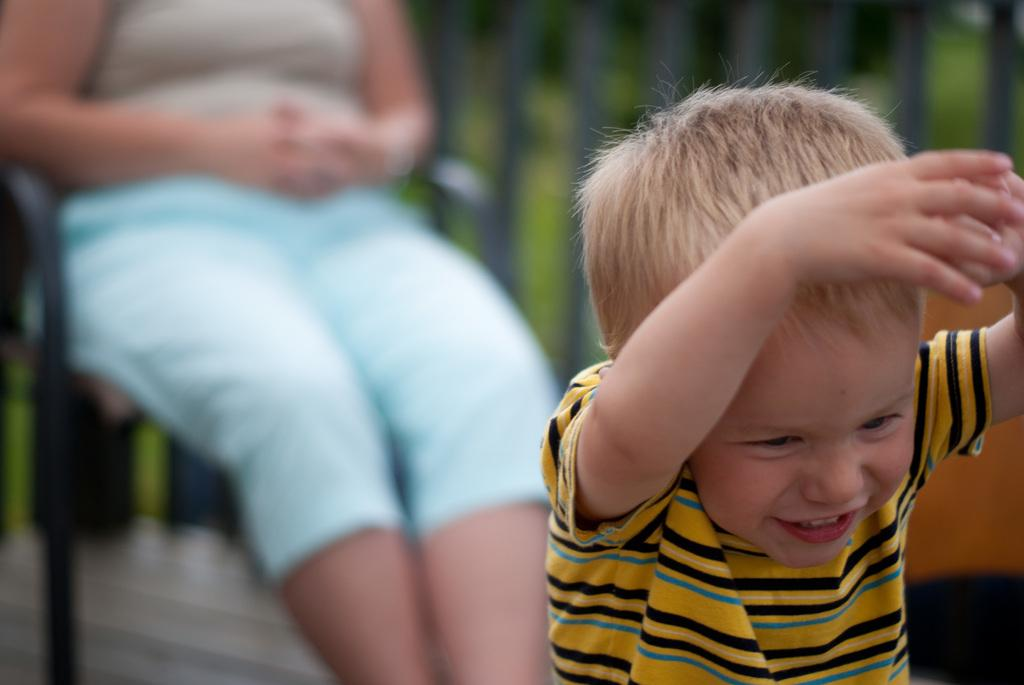Who is the main subject on the right side of the image? There is a small boy on the right side of the image. What is the lady doing in the image? The lady is sitting on a chair in the image. Where is the chair located in the image? The chair is in the background area of the image. What type of magic is the small boy performing in the image? There is no magic or any indication of magical activity in the image. Can you tell me where the faucet is located in the image? There is no faucet present in the image. 